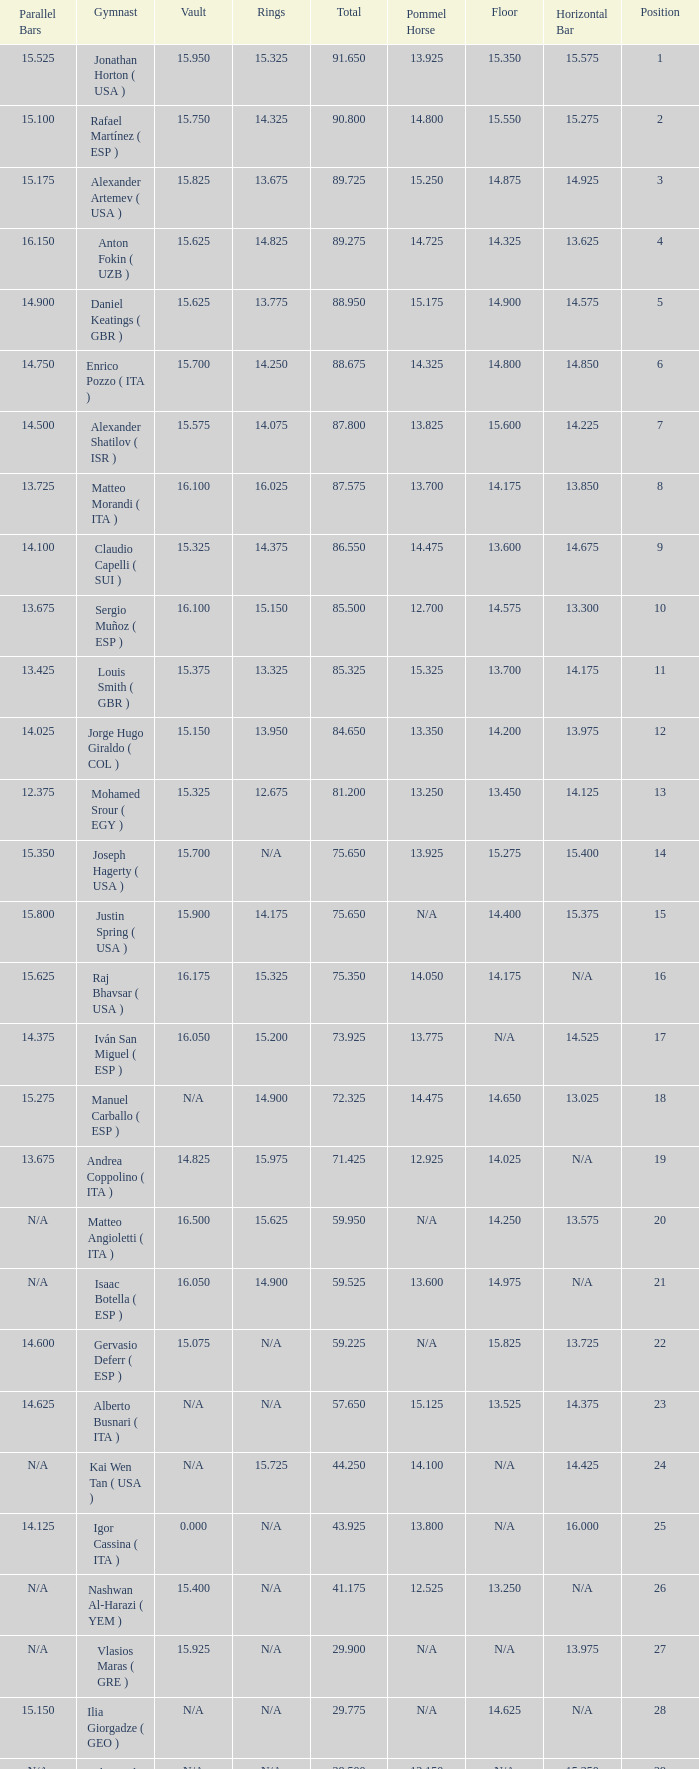If the parallel bars is 14.025, what is the total number of gymnasts? 1.0. 